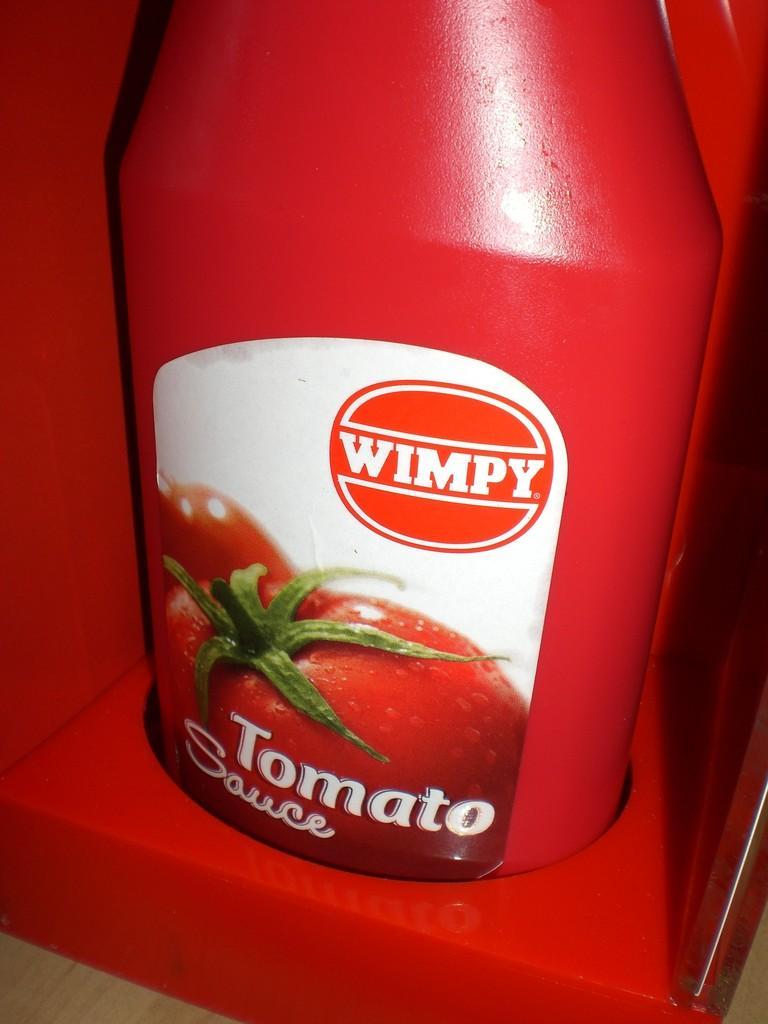In one or two sentences, can you explain what this image depicts? In this image I see the red color bottle on which there is a sticker and I see 3 words and tomatoes over here and this bottle is on a red color thing. 